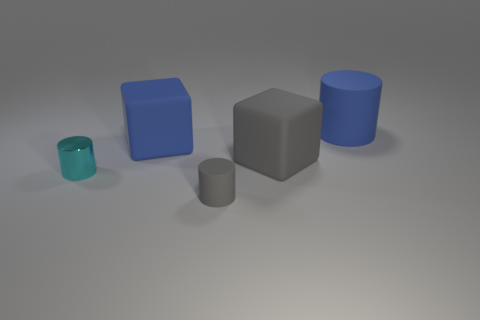Is the material of the large gray object the same as the small object that is in front of the cyan metallic thing?
Provide a succinct answer. Yes. Are there more big cylinders that are behind the large rubber cylinder than blue rubber objects that are behind the large blue block?
Your answer should be compact. No. The tiny gray matte object is what shape?
Your response must be concise. Cylinder. Does the tiny cylinder that is right of the metallic object have the same material as the big thing behind the blue rubber cube?
Make the answer very short. Yes. What shape is the big object that is on the right side of the large gray rubber object?
Keep it short and to the point. Cylinder. What size is the cyan shiny object that is the same shape as the small gray thing?
Provide a short and direct response. Small. Do the large cylinder and the small metallic cylinder have the same color?
Your response must be concise. No. Are there any other things that are the same shape as the small matte thing?
Your answer should be very brief. Yes. Are there any small gray objects to the left of the cylinder that is on the right side of the gray cylinder?
Give a very brief answer. Yes. There is another object that is the same shape as the big gray matte thing; what color is it?
Offer a terse response. Blue. 